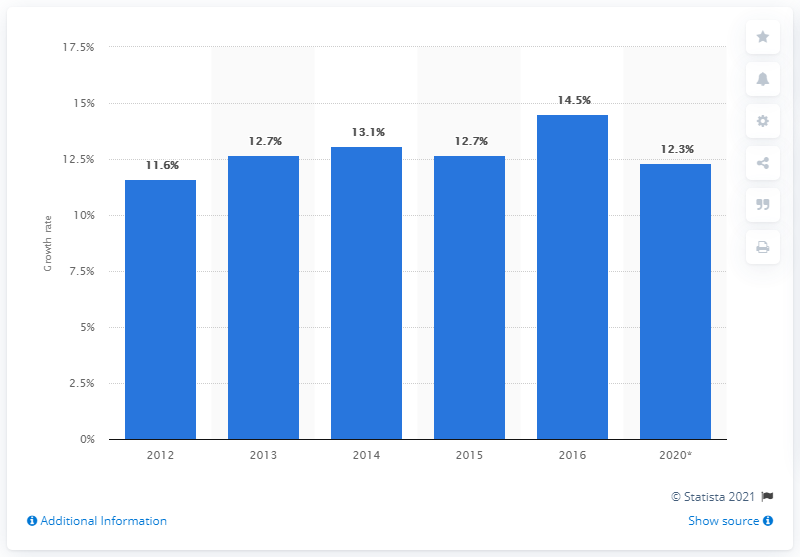Outline some significant characteristics in this image. The express and small parcels market in Asia Pacific grew by 14.5% in 2016. 